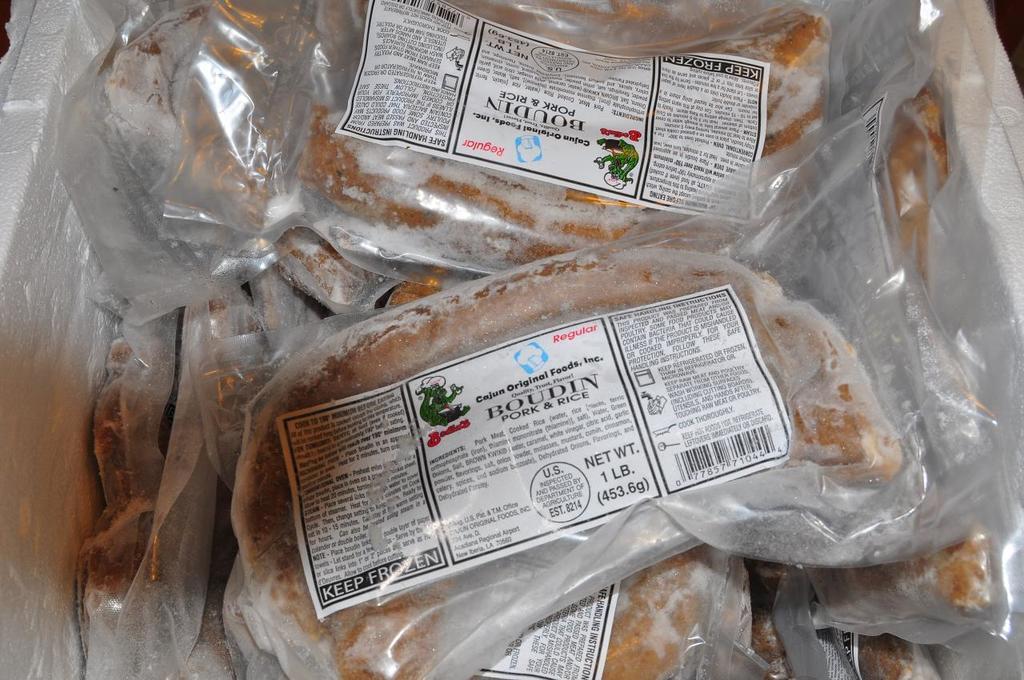Describe this image in one or two sentences. There are food items packed with plastic covers along with papers. 